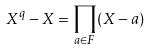<formula> <loc_0><loc_0><loc_500><loc_500>X ^ { q } - X = \prod _ { a \in F } ( X - a )</formula> 